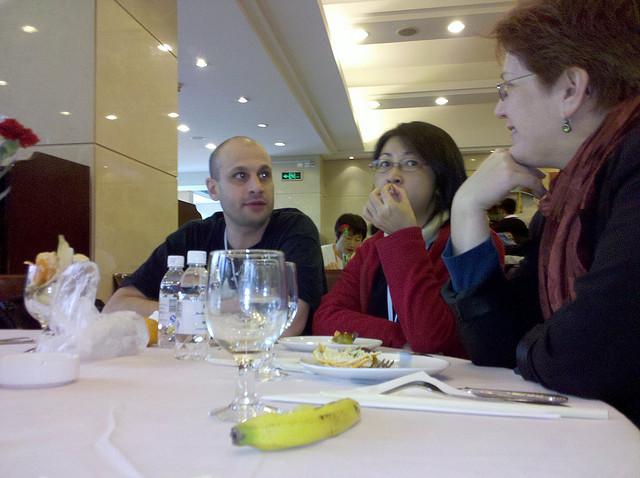Are the glasses empty?
Concise answer only. Yes. How many forks are right side up?
Concise answer only. 1. Is there fruit on the table?
Keep it brief. Yes. Is she smiling about something she did?
Be succinct. No. What fruit is on the table?
Concise answer only. Banana. What point in the meal are these women taking pictures?
Quick response, please. Dessert. How many people are at the table?
Quick response, please. 3. What kind of wine is in the glasses?
Answer briefly. White. Are there any adults pictured?
Concise answer only. Yes. Are all cups filled with fluid?
Keep it brief. No. 